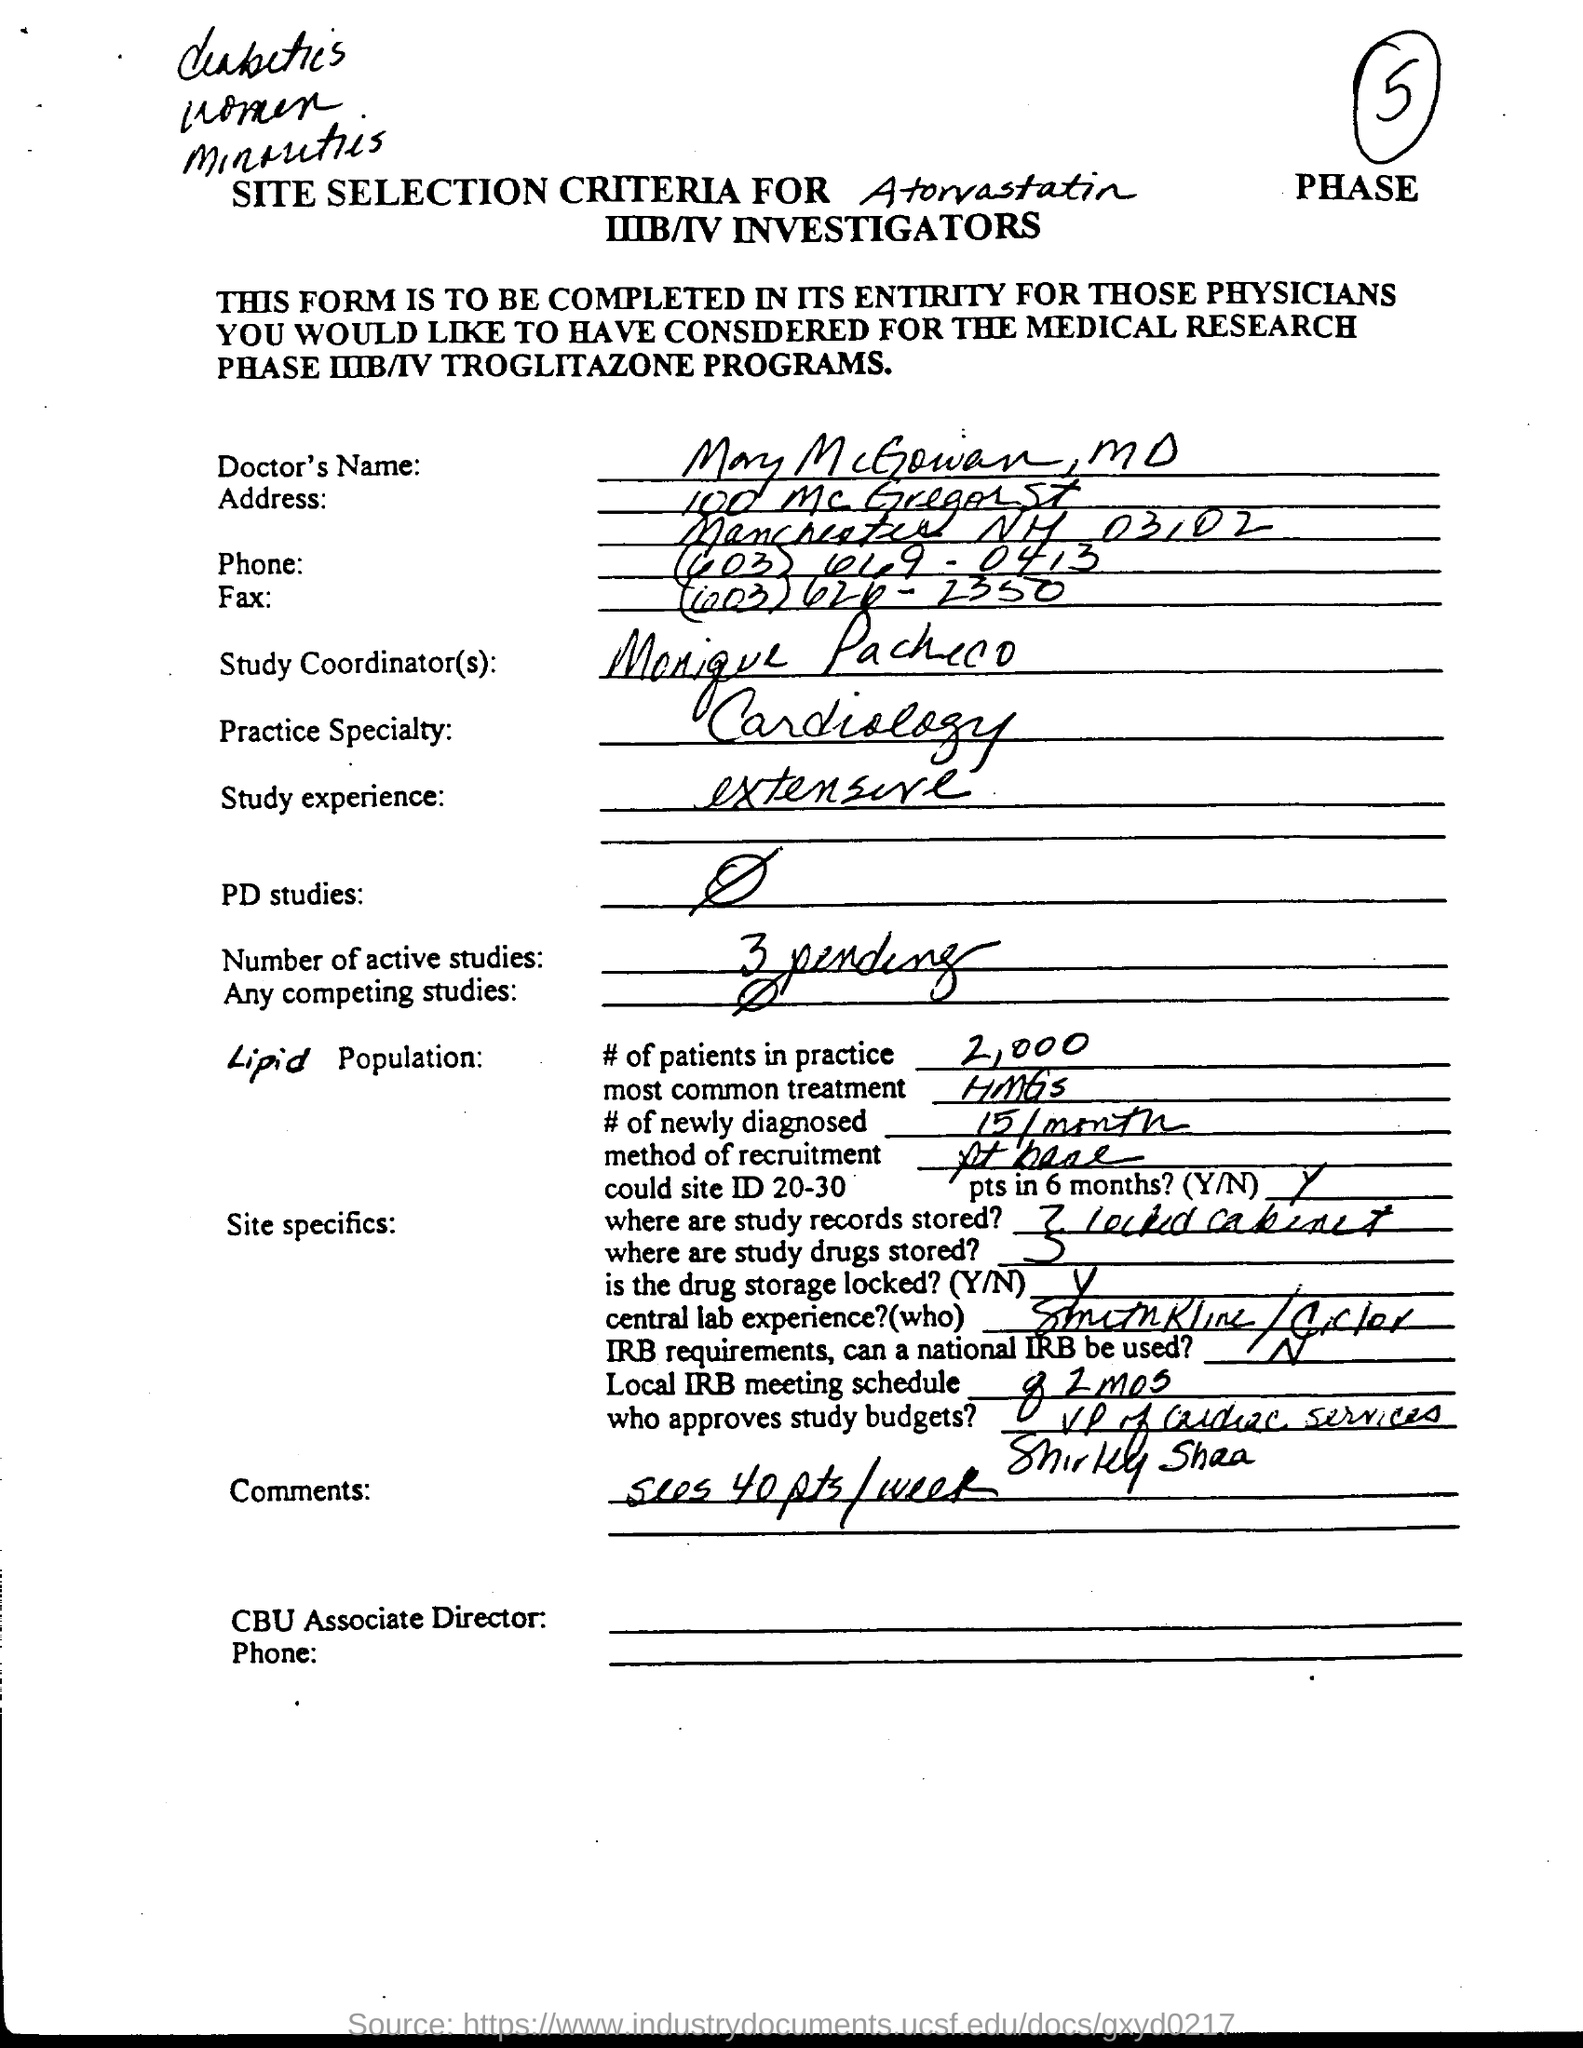Draw attention to some important aspects in this diagram. There are three pending studies currently active. The study experience is extensive and provides a comprehensive understanding of the subject matter. 